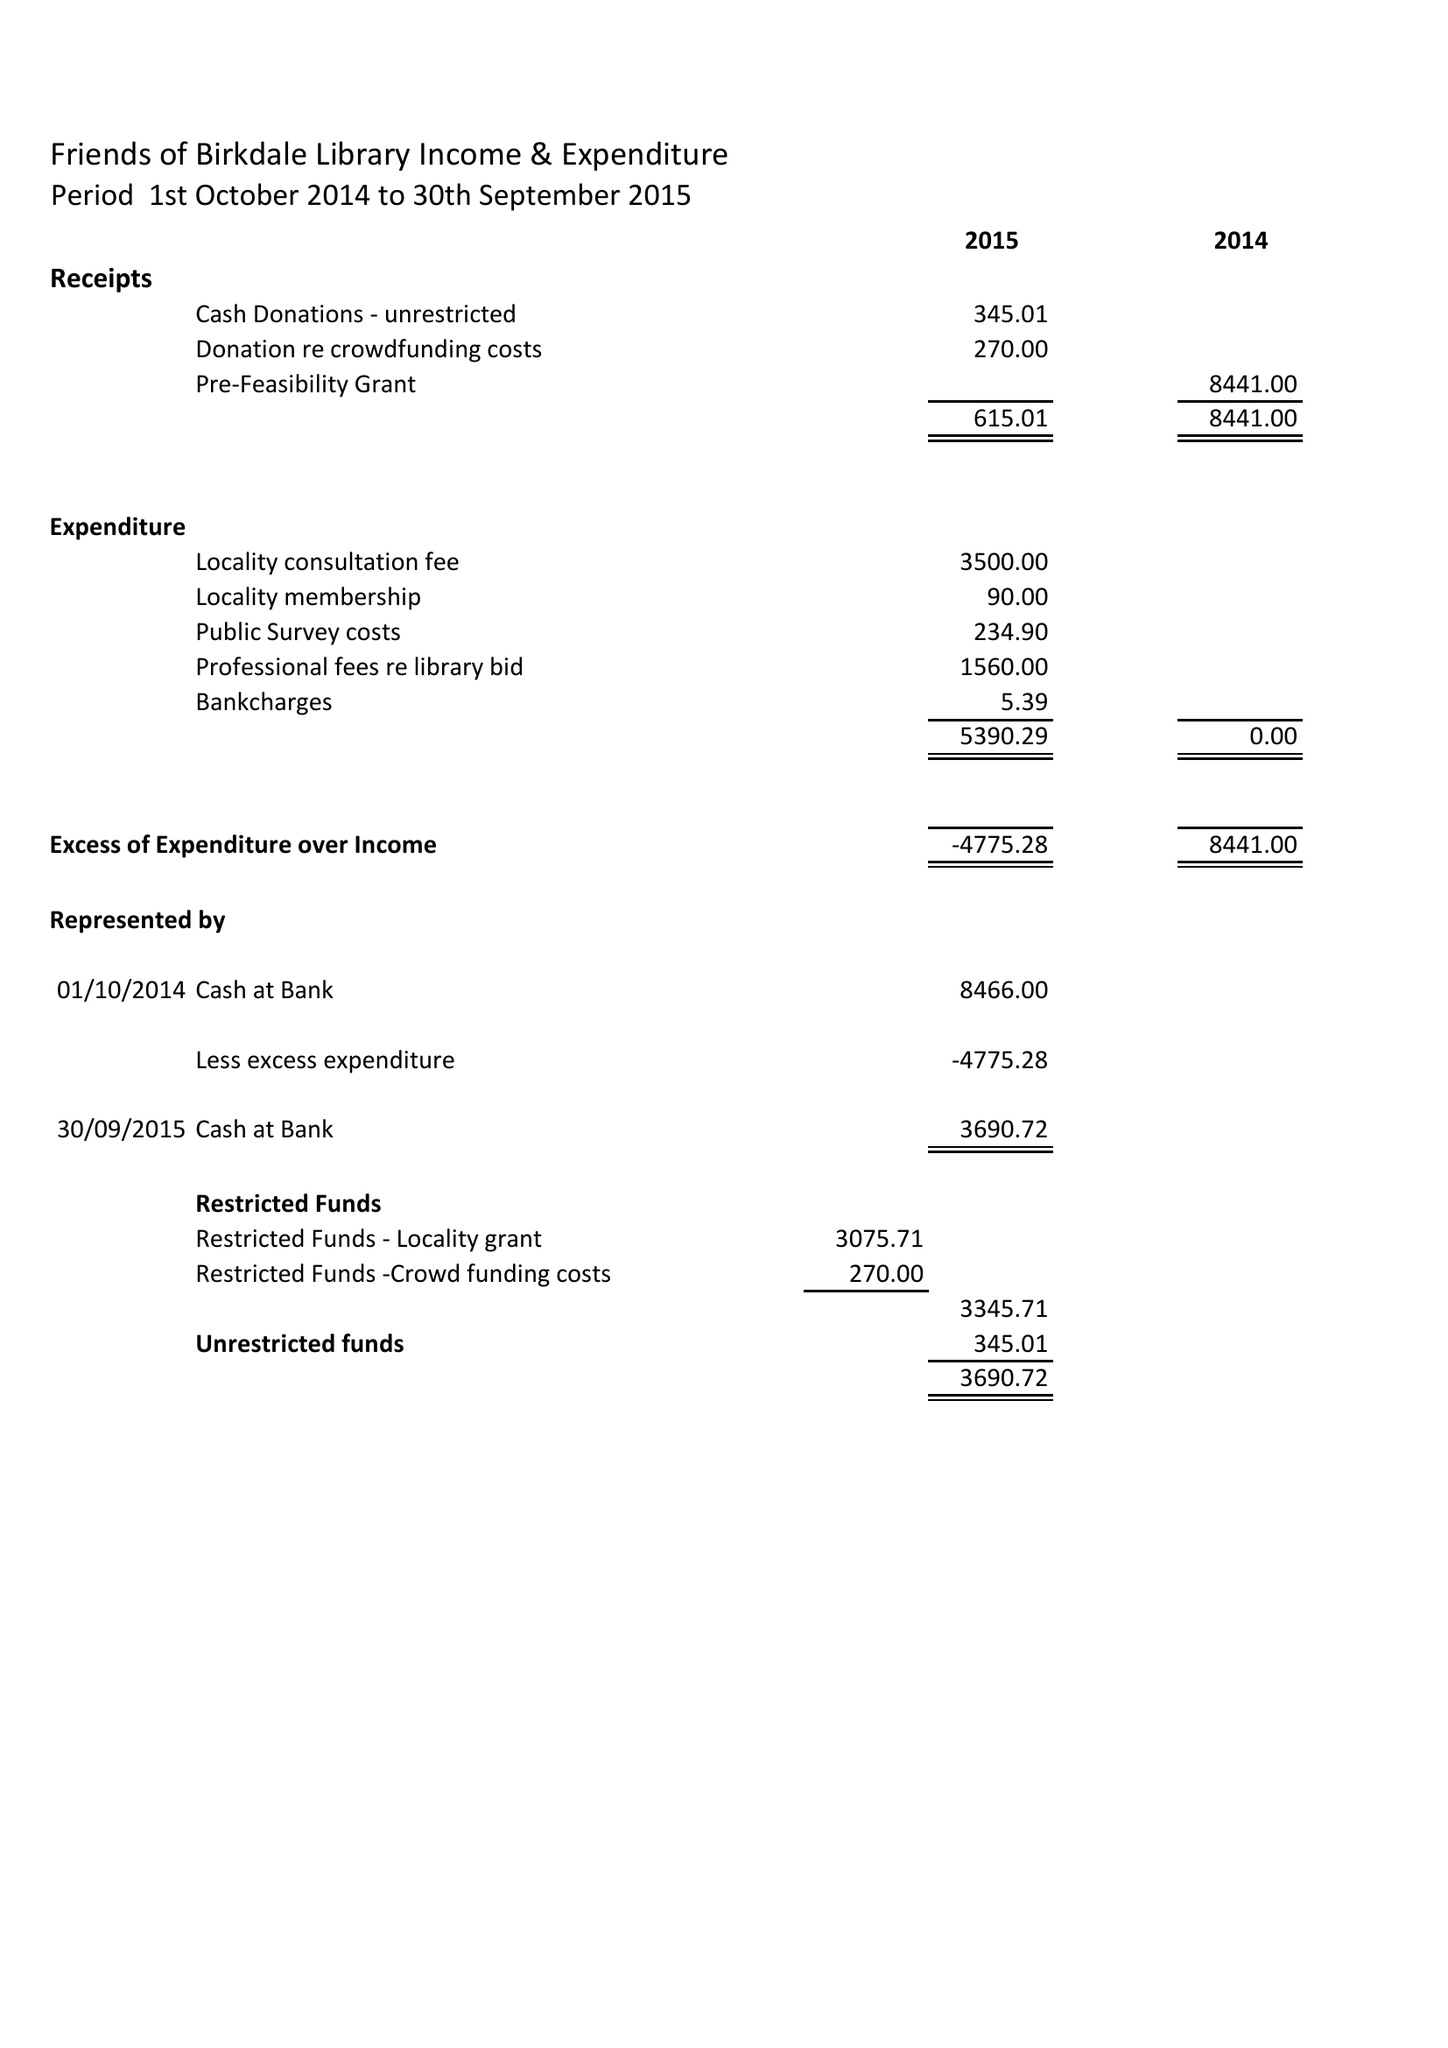What is the value for the income_annually_in_british_pounds?
Answer the question using a single word or phrase. 615.00 